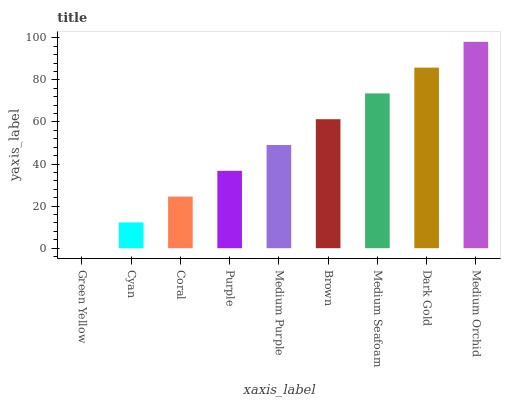Is Cyan the minimum?
Answer yes or no. No. Is Cyan the maximum?
Answer yes or no. No. Is Cyan greater than Green Yellow?
Answer yes or no. Yes. Is Green Yellow less than Cyan?
Answer yes or no. Yes. Is Green Yellow greater than Cyan?
Answer yes or no. No. Is Cyan less than Green Yellow?
Answer yes or no. No. Is Medium Purple the high median?
Answer yes or no. Yes. Is Medium Purple the low median?
Answer yes or no. Yes. Is Dark Gold the high median?
Answer yes or no. No. Is Brown the low median?
Answer yes or no. No. 